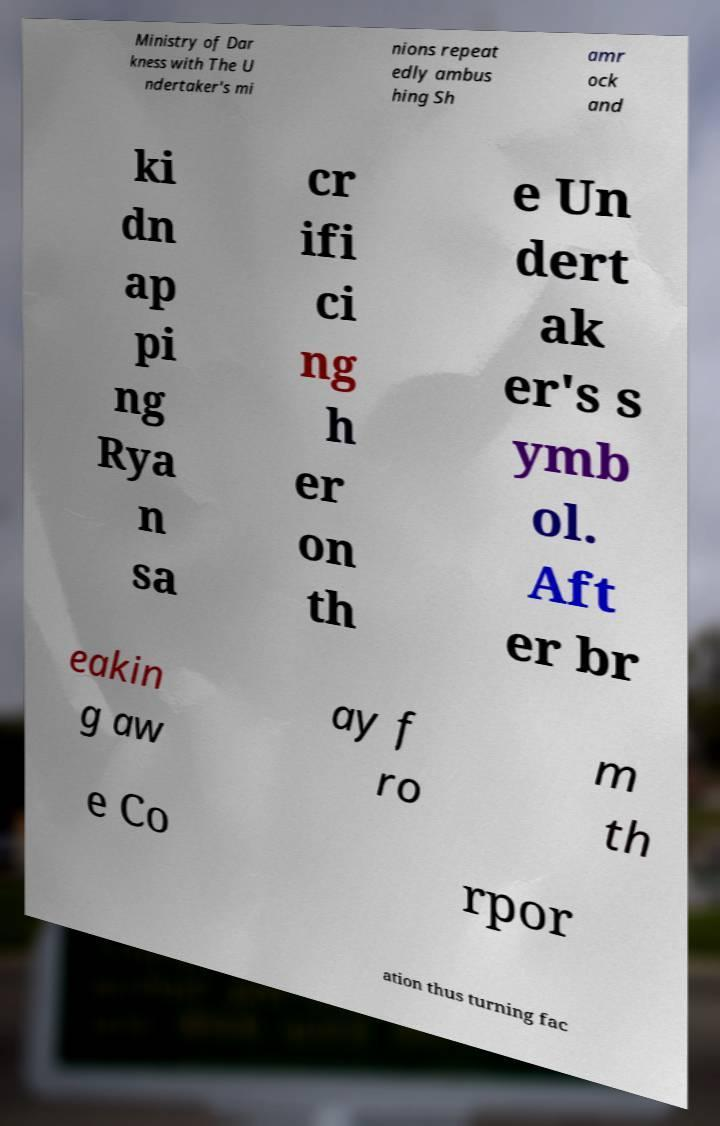Could you assist in decoding the text presented in this image and type it out clearly? Ministry of Dar kness with The U ndertaker's mi nions repeat edly ambus hing Sh amr ock and ki dn ap pi ng Rya n sa cr ifi ci ng h er on th e Un dert ak er's s ymb ol. Aft er br eakin g aw ay f ro m th e Co rpor ation thus turning fac 